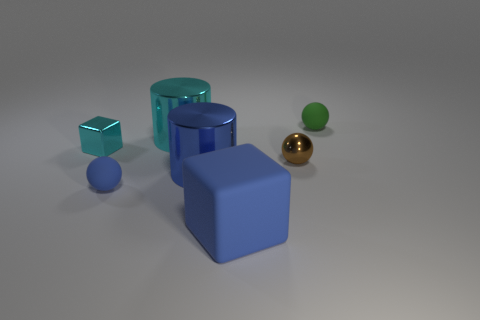Does the large object in front of the blue metal cylinder have the same material as the cyan thing in front of the cyan metal cylinder? The large object in front of the blue metal cylinder appears to be a blue cube made from a matte material, whereas the cyan object in front of the cyan metal cylinder, which seems to be a small cube, also has a matte finish. Despite both objects appearing to have a similar matte texture, without more context or specific material properties, it's not definitive if they are made of the exact same material. However, they do share visual similarities in their finishes. 